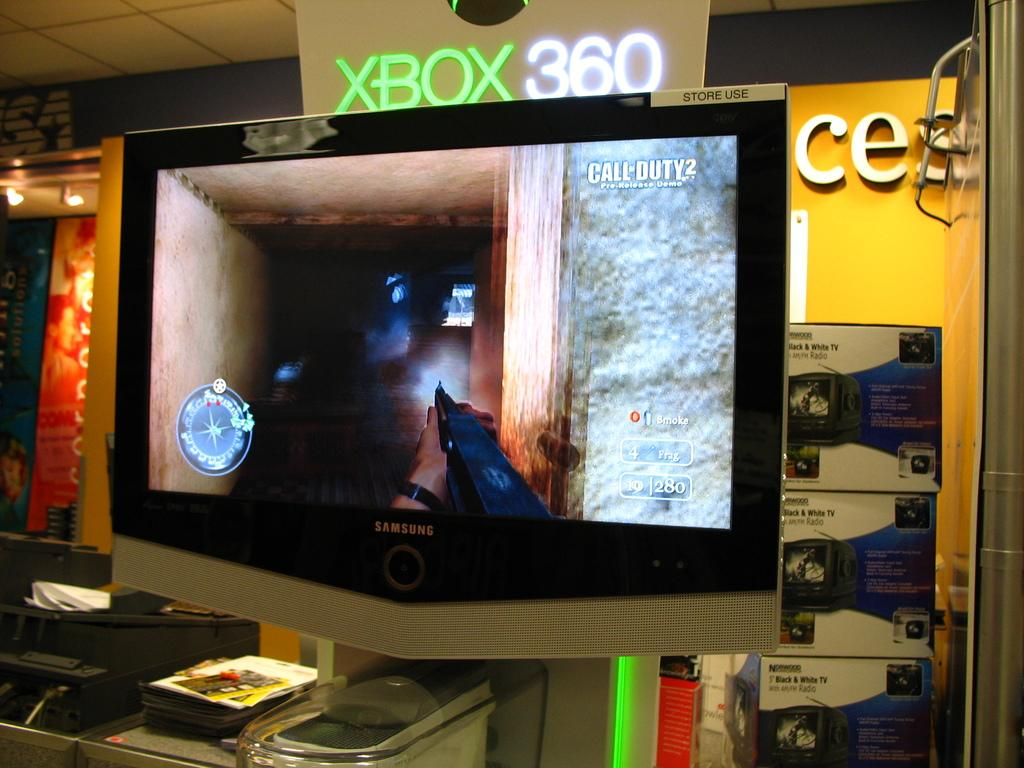<image>
Describe the image concisely. Someone playing Call of Duty 2 pre release demo on the monitor 